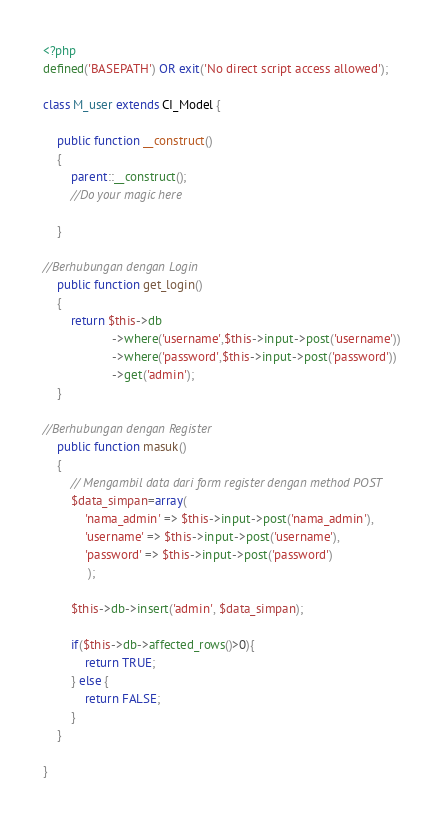<code> <loc_0><loc_0><loc_500><loc_500><_PHP_><?php
defined('BASEPATH') OR exit('No direct script access allowed');

class M_user extends CI_Model {

	public function __construct()
	{
		parent::__construct();
		//Do your magic here

	}

//Berhubungan dengan Login
	public function get_login()
	{
		return $this->db
					->where('username',$this->input->post('username'))
					->where('password',$this->input->post('password'))
					->get('admin');
	}

//Berhubungan dengan Register
	public function masuk()
	{
		// Mengambil data dari form register dengan method POST
		$data_simpan=array(
			'nama_admin' => $this->input->post('nama_admin'),
			'username' => $this->input->post('username'),
			'password' => $this->input->post('password')
			 );

		$this->db->insert('admin', $data_simpan);

		if($this->db->affected_rows()>0){
			return TRUE;
		} else {
			return FALSE;
		}
	}

}</code> 